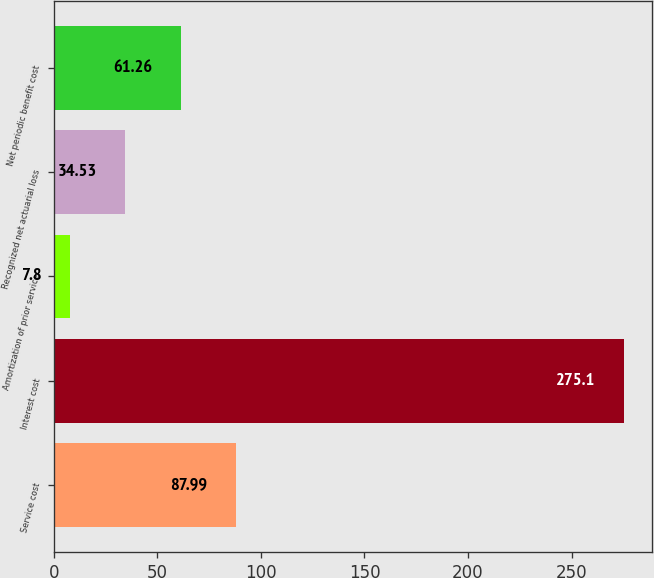Convert chart. <chart><loc_0><loc_0><loc_500><loc_500><bar_chart><fcel>Service cost<fcel>Interest cost<fcel>Amortization of prior service<fcel>Recognized net actuarial loss<fcel>Net periodic benefit cost<nl><fcel>87.99<fcel>275.1<fcel>7.8<fcel>34.53<fcel>61.26<nl></chart> 